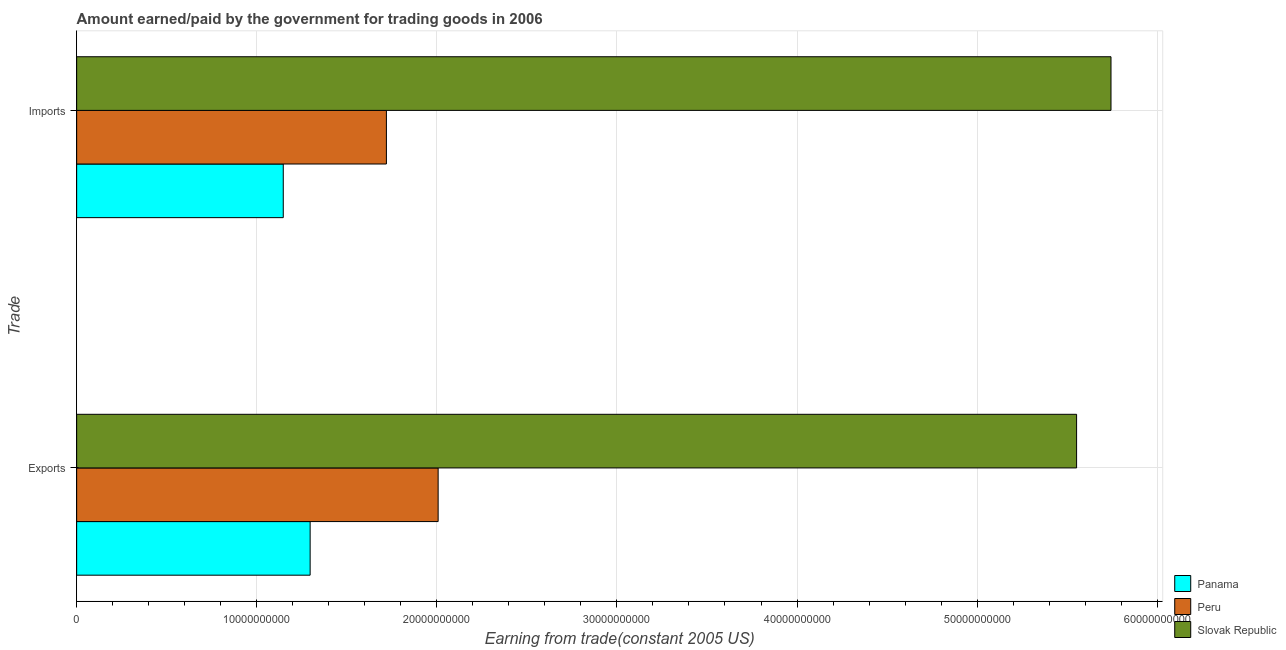How many different coloured bars are there?
Provide a succinct answer. 3. Are the number of bars per tick equal to the number of legend labels?
Your response must be concise. Yes. Are the number of bars on each tick of the Y-axis equal?
Keep it short and to the point. Yes. How many bars are there on the 1st tick from the bottom?
Give a very brief answer. 3. What is the label of the 1st group of bars from the top?
Provide a short and direct response. Imports. What is the amount earned from exports in Peru?
Ensure brevity in your answer.  2.01e+1. Across all countries, what is the maximum amount paid for imports?
Provide a succinct answer. 5.74e+1. Across all countries, what is the minimum amount earned from exports?
Ensure brevity in your answer.  1.30e+1. In which country was the amount paid for imports maximum?
Offer a terse response. Slovak Republic. In which country was the amount earned from exports minimum?
Keep it short and to the point. Panama. What is the total amount paid for imports in the graph?
Your answer should be very brief. 8.61e+1. What is the difference between the amount paid for imports in Slovak Republic and that in Peru?
Keep it short and to the point. 4.02e+1. What is the difference between the amount paid for imports in Slovak Republic and the amount earned from exports in Panama?
Offer a terse response. 4.45e+1. What is the average amount paid for imports per country?
Your answer should be very brief. 2.87e+1. What is the difference between the amount earned from exports and amount paid for imports in Slovak Republic?
Make the answer very short. -1.91e+09. In how many countries, is the amount paid for imports greater than 38000000000 US$?
Offer a very short reply. 1. What is the ratio of the amount paid for imports in Peru to that in Panama?
Make the answer very short. 1.5. Is the amount paid for imports in Slovak Republic less than that in Peru?
Make the answer very short. No. What does the 1st bar from the top in Imports represents?
Keep it short and to the point. Slovak Republic. What does the 2nd bar from the bottom in Exports represents?
Make the answer very short. Peru. How many countries are there in the graph?
Provide a short and direct response. 3. What is the difference between two consecutive major ticks on the X-axis?
Give a very brief answer. 1.00e+1. Are the values on the major ticks of X-axis written in scientific E-notation?
Give a very brief answer. No. Does the graph contain any zero values?
Your response must be concise. No. Where does the legend appear in the graph?
Make the answer very short. Bottom right. How many legend labels are there?
Provide a succinct answer. 3. How are the legend labels stacked?
Your response must be concise. Vertical. What is the title of the graph?
Your response must be concise. Amount earned/paid by the government for trading goods in 2006. What is the label or title of the X-axis?
Ensure brevity in your answer.  Earning from trade(constant 2005 US). What is the label or title of the Y-axis?
Offer a very short reply. Trade. What is the Earning from trade(constant 2005 US) in Panama in Exports?
Offer a very short reply. 1.30e+1. What is the Earning from trade(constant 2005 US) of Peru in Exports?
Give a very brief answer. 2.01e+1. What is the Earning from trade(constant 2005 US) of Slovak Republic in Exports?
Ensure brevity in your answer.  5.55e+1. What is the Earning from trade(constant 2005 US) of Panama in Imports?
Make the answer very short. 1.15e+1. What is the Earning from trade(constant 2005 US) in Peru in Imports?
Make the answer very short. 1.72e+1. What is the Earning from trade(constant 2005 US) in Slovak Republic in Imports?
Provide a succinct answer. 5.74e+1. Across all Trade, what is the maximum Earning from trade(constant 2005 US) of Panama?
Ensure brevity in your answer.  1.30e+1. Across all Trade, what is the maximum Earning from trade(constant 2005 US) in Peru?
Your answer should be very brief. 2.01e+1. Across all Trade, what is the maximum Earning from trade(constant 2005 US) of Slovak Republic?
Your response must be concise. 5.74e+1. Across all Trade, what is the minimum Earning from trade(constant 2005 US) in Panama?
Your response must be concise. 1.15e+1. Across all Trade, what is the minimum Earning from trade(constant 2005 US) of Peru?
Offer a terse response. 1.72e+1. Across all Trade, what is the minimum Earning from trade(constant 2005 US) of Slovak Republic?
Ensure brevity in your answer.  5.55e+1. What is the total Earning from trade(constant 2005 US) of Panama in the graph?
Offer a terse response. 2.44e+1. What is the total Earning from trade(constant 2005 US) in Peru in the graph?
Keep it short and to the point. 3.73e+1. What is the total Earning from trade(constant 2005 US) in Slovak Republic in the graph?
Provide a succinct answer. 1.13e+11. What is the difference between the Earning from trade(constant 2005 US) in Panama in Exports and that in Imports?
Make the answer very short. 1.49e+09. What is the difference between the Earning from trade(constant 2005 US) of Peru in Exports and that in Imports?
Your answer should be very brief. 2.87e+09. What is the difference between the Earning from trade(constant 2005 US) of Slovak Republic in Exports and that in Imports?
Make the answer very short. -1.91e+09. What is the difference between the Earning from trade(constant 2005 US) in Panama in Exports and the Earning from trade(constant 2005 US) in Peru in Imports?
Give a very brief answer. -4.24e+09. What is the difference between the Earning from trade(constant 2005 US) of Panama in Exports and the Earning from trade(constant 2005 US) of Slovak Republic in Imports?
Provide a succinct answer. -4.45e+1. What is the difference between the Earning from trade(constant 2005 US) of Peru in Exports and the Earning from trade(constant 2005 US) of Slovak Republic in Imports?
Ensure brevity in your answer.  -3.74e+1. What is the average Earning from trade(constant 2005 US) of Panama per Trade?
Offer a terse response. 1.22e+1. What is the average Earning from trade(constant 2005 US) in Peru per Trade?
Provide a short and direct response. 1.86e+1. What is the average Earning from trade(constant 2005 US) of Slovak Republic per Trade?
Make the answer very short. 5.65e+1. What is the difference between the Earning from trade(constant 2005 US) of Panama and Earning from trade(constant 2005 US) of Peru in Exports?
Offer a terse response. -7.11e+09. What is the difference between the Earning from trade(constant 2005 US) of Panama and Earning from trade(constant 2005 US) of Slovak Republic in Exports?
Keep it short and to the point. -4.26e+1. What is the difference between the Earning from trade(constant 2005 US) in Peru and Earning from trade(constant 2005 US) in Slovak Republic in Exports?
Provide a succinct answer. -3.55e+1. What is the difference between the Earning from trade(constant 2005 US) in Panama and Earning from trade(constant 2005 US) in Peru in Imports?
Give a very brief answer. -5.73e+09. What is the difference between the Earning from trade(constant 2005 US) of Panama and Earning from trade(constant 2005 US) of Slovak Republic in Imports?
Your response must be concise. -4.60e+1. What is the difference between the Earning from trade(constant 2005 US) of Peru and Earning from trade(constant 2005 US) of Slovak Republic in Imports?
Offer a terse response. -4.02e+1. What is the ratio of the Earning from trade(constant 2005 US) in Panama in Exports to that in Imports?
Provide a short and direct response. 1.13. What is the ratio of the Earning from trade(constant 2005 US) in Peru in Exports to that in Imports?
Keep it short and to the point. 1.17. What is the ratio of the Earning from trade(constant 2005 US) in Slovak Republic in Exports to that in Imports?
Provide a succinct answer. 0.97. What is the difference between the highest and the second highest Earning from trade(constant 2005 US) of Panama?
Ensure brevity in your answer.  1.49e+09. What is the difference between the highest and the second highest Earning from trade(constant 2005 US) in Peru?
Your answer should be very brief. 2.87e+09. What is the difference between the highest and the second highest Earning from trade(constant 2005 US) in Slovak Republic?
Provide a succinct answer. 1.91e+09. What is the difference between the highest and the lowest Earning from trade(constant 2005 US) in Panama?
Give a very brief answer. 1.49e+09. What is the difference between the highest and the lowest Earning from trade(constant 2005 US) in Peru?
Offer a very short reply. 2.87e+09. What is the difference between the highest and the lowest Earning from trade(constant 2005 US) in Slovak Republic?
Give a very brief answer. 1.91e+09. 